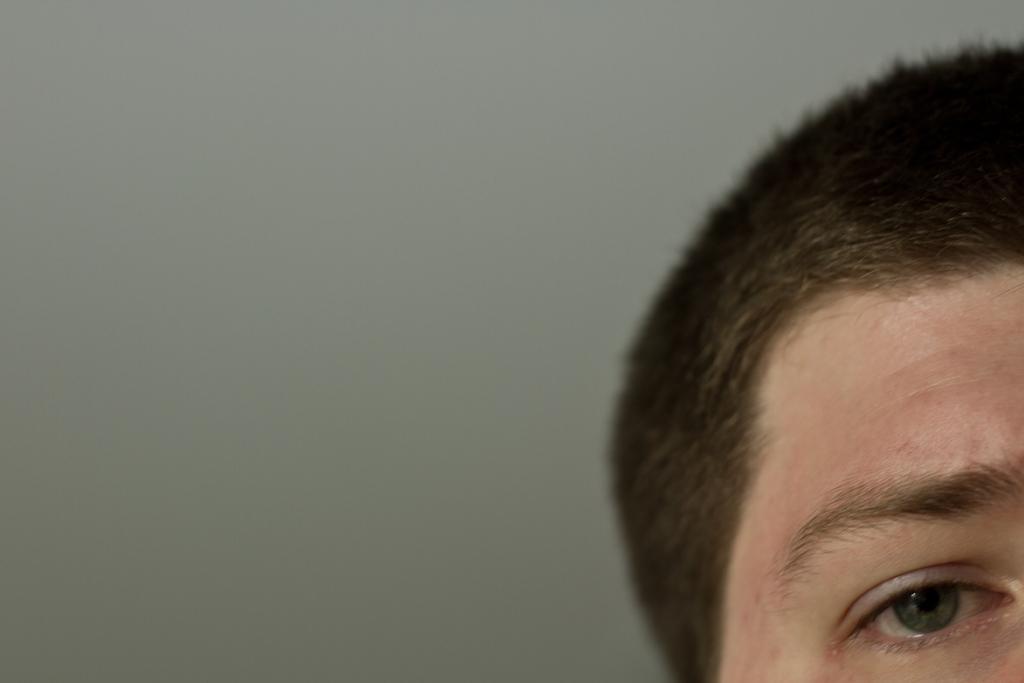In one or two sentences, can you explain what this image depicts? Here in this picture we can see some part of head and an eye present over there. 